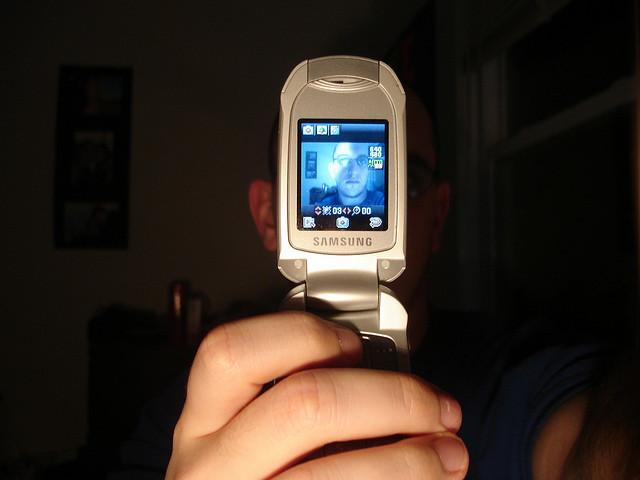What company makes the phone? samsung 